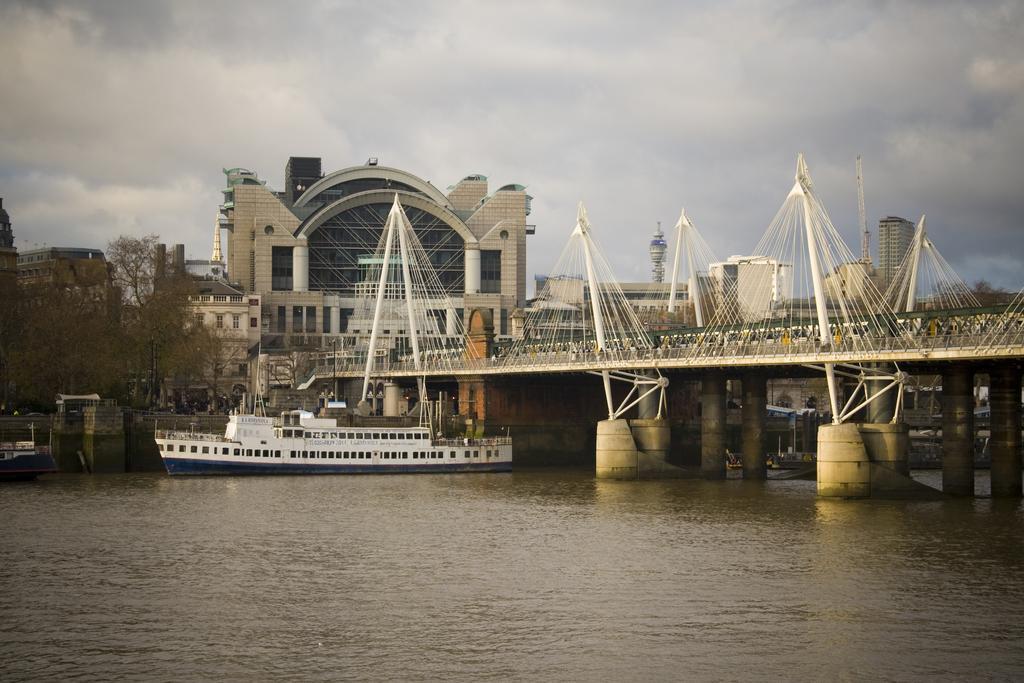How would you summarize this image in a sentence or two? In this picture I can see there is a sea, there is a boat sailing, there is a bridge at right and there are few buildings in the backdrop and there is a tree at the left side and the sky is clear. 